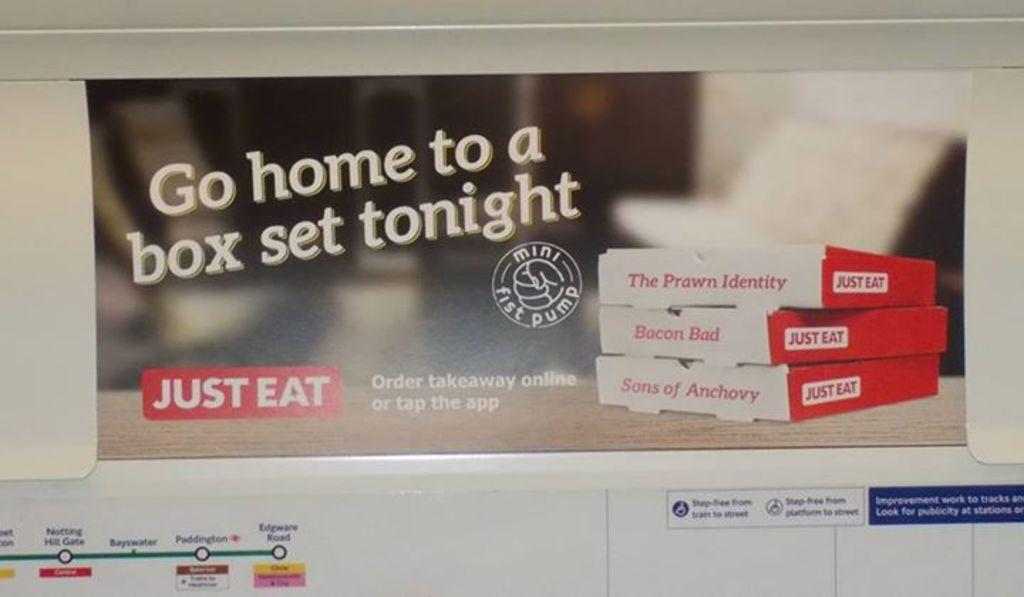Provide a one-sentence caption for the provided image. An advertisement suggests that we go home to a box set tonight. 